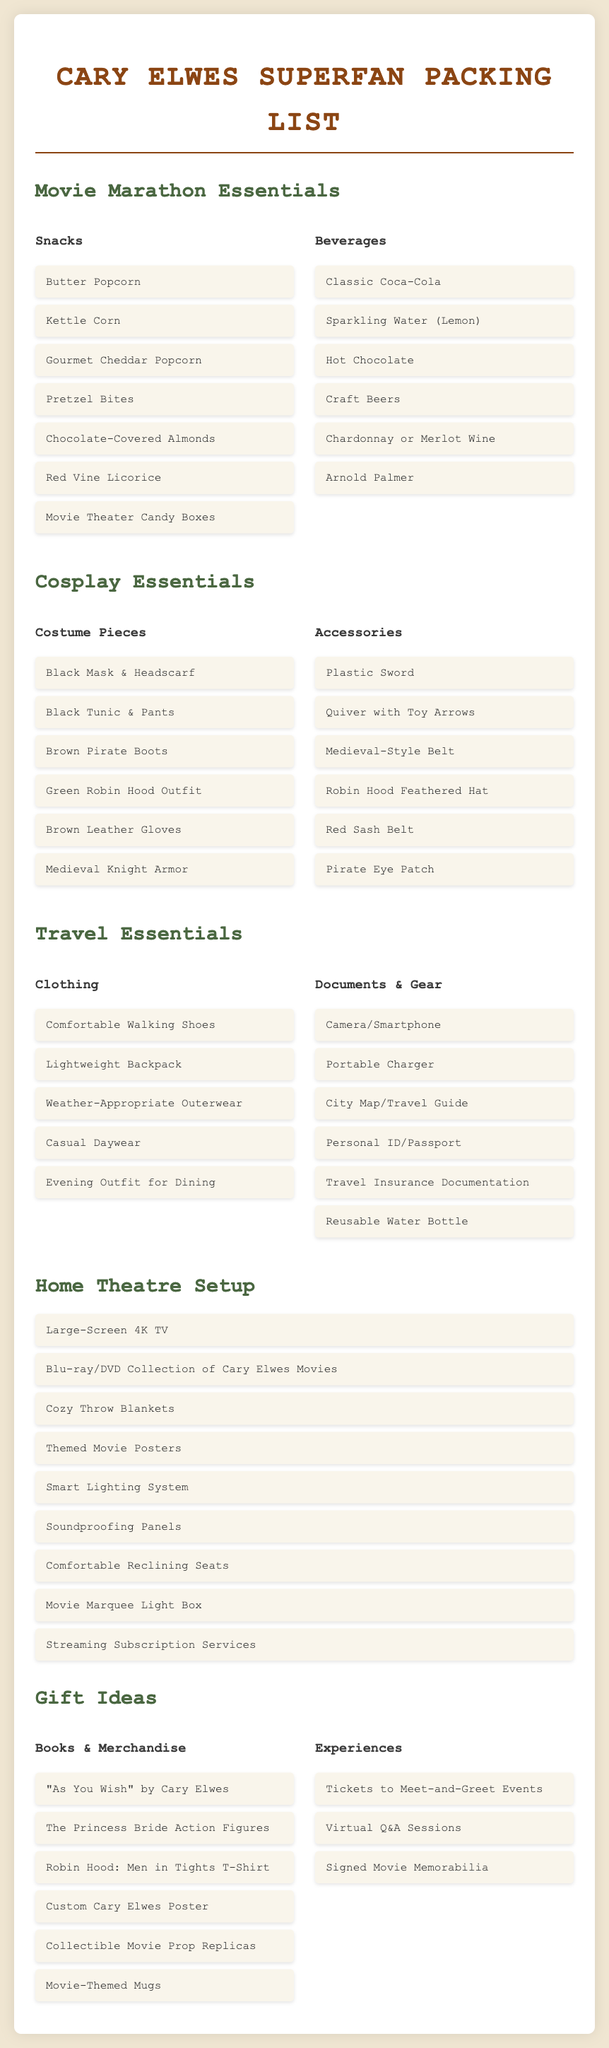What snacks are included for the movie marathon? The snacks section lists various food items specifically for the movie marathon, including Butter Popcorn, Kettle Corn, and others.
Answer: Butter Popcorn, Kettle Corn, Gourmet Cheddar Popcorn, Pretzel Bites, Chocolate-Covered Almonds, Red Vine Licorice, Movie Theater Candy Boxes What is a recommended drink for the movie marathon? The beverages section suggests drinks for enjoying during a movie marathon, such as Classic Coca-Cola and others.
Answer: Classic Coca-Cola How many costume pieces are listed in the cosplay essentials? The costume pieces section contains a list of items, counting the number of unique pieces provided.
Answer: Six Which Cary Elwes movie outfit can you cosplay with a brown pirate boots? The document lists specific outfit pieces, including Brown Pirate Boots among the costumes.
Answer: Brown Pirate Boots What is one example of an experience gift for a Cary Elwes superfan? The gifts section includes experience-based gifts that can be given to fans, such as tickets to events.
Answer: Tickets to Meet-and-Greet Events How many items are listed in the Home Theatre Setup? The home theatre setup section enumerates the items necessary for a perfect viewing experience, and counts them.
Answer: Nine What type of beverage is mentioned that includes lemon? The beverages section specifies a drink that has a lemon flavor.
Answer: Sparkling Water (Lemon) What is the title of Cary Elwes' book that is suggested as a gift? The gifts section lists various books and merchandise, including Cary Elwes' autobiography.
Answer: "As You Wish" by Cary Elwes 